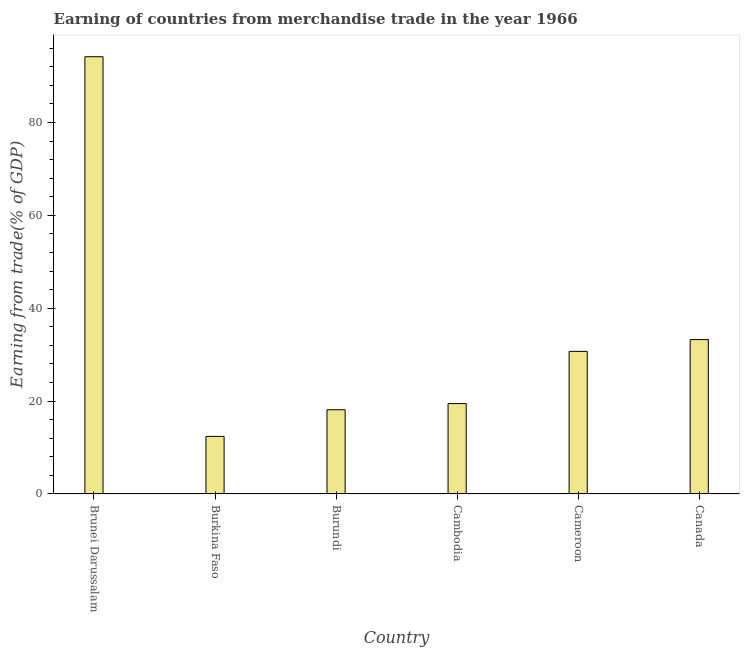Does the graph contain grids?
Keep it short and to the point. No. What is the title of the graph?
Provide a short and direct response. Earning of countries from merchandise trade in the year 1966. What is the label or title of the Y-axis?
Your answer should be compact. Earning from trade(% of GDP). What is the earning from merchandise trade in Cambodia?
Keep it short and to the point. 19.47. Across all countries, what is the maximum earning from merchandise trade?
Offer a very short reply. 94.16. Across all countries, what is the minimum earning from merchandise trade?
Give a very brief answer. 12.4. In which country was the earning from merchandise trade maximum?
Ensure brevity in your answer.  Brunei Darussalam. In which country was the earning from merchandise trade minimum?
Your response must be concise. Burkina Faso. What is the sum of the earning from merchandise trade?
Offer a terse response. 208.11. What is the difference between the earning from merchandise trade in Burkina Faso and Canada?
Provide a succinct answer. -20.85. What is the average earning from merchandise trade per country?
Make the answer very short. 34.69. What is the median earning from merchandise trade?
Keep it short and to the point. 25.09. In how many countries, is the earning from merchandise trade greater than 4 %?
Make the answer very short. 6. What is the ratio of the earning from merchandise trade in Cameroon to that in Canada?
Ensure brevity in your answer.  0.92. Is the difference between the earning from merchandise trade in Burkina Faso and Cameroon greater than the difference between any two countries?
Provide a succinct answer. No. What is the difference between the highest and the second highest earning from merchandise trade?
Provide a succinct answer. 60.91. Is the sum of the earning from merchandise trade in Burundi and Canada greater than the maximum earning from merchandise trade across all countries?
Give a very brief answer. No. What is the difference between the highest and the lowest earning from merchandise trade?
Give a very brief answer. 81.76. Are the values on the major ticks of Y-axis written in scientific E-notation?
Your response must be concise. No. What is the Earning from trade(% of GDP) in Brunei Darussalam?
Your answer should be compact. 94.16. What is the Earning from trade(% of GDP) in Burkina Faso?
Provide a succinct answer. 12.4. What is the Earning from trade(% of GDP) of Burundi?
Keep it short and to the point. 18.13. What is the Earning from trade(% of GDP) in Cambodia?
Make the answer very short. 19.47. What is the Earning from trade(% of GDP) in Cameroon?
Keep it short and to the point. 30.71. What is the Earning from trade(% of GDP) in Canada?
Offer a terse response. 33.25. What is the difference between the Earning from trade(% of GDP) in Brunei Darussalam and Burkina Faso?
Give a very brief answer. 81.76. What is the difference between the Earning from trade(% of GDP) in Brunei Darussalam and Burundi?
Give a very brief answer. 76.02. What is the difference between the Earning from trade(% of GDP) in Brunei Darussalam and Cambodia?
Keep it short and to the point. 74.69. What is the difference between the Earning from trade(% of GDP) in Brunei Darussalam and Cameroon?
Your answer should be compact. 63.45. What is the difference between the Earning from trade(% of GDP) in Brunei Darussalam and Canada?
Make the answer very short. 60.91. What is the difference between the Earning from trade(% of GDP) in Burkina Faso and Burundi?
Your answer should be very brief. -5.74. What is the difference between the Earning from trade(% of GDP) in Burkina Faso and Cambodia?
Make the answer very short. -7.07. What is the difference between the Earning from trade(% of GDP) in Burkina Faso and Cameroon?
Provide a succinct answer. -18.31. What is the difference between the Earning from trade(% of GDP) in Burkina Faso and Canada?
Offer a very short reply. -20.85. What is the difference between the Earning from trade(% of GDP) in Burundi and Cambodia?
Your answer should be very brief. -1.34. What is the difference between the Earning from trade(% of GDP) in Burundi and Cameroon?
Give a very brief answer. -12.58. What is the difference between the Earning from trade(% of GDP) in Burundi and Canada?
Provide a short and direct response. -15.11. What is the difference between the Earning from trade(% of GDP) in Cambodia and Cameroon?
Keep it short and to the point. -11.24. What is the difference between the Earning from trade(% of GDP) in Cambodia and Canada?
Ensure brevity in your answer.  -13.78. What is the difference between the Earning from trade(% of GDP) in Cameroon and Canada?
Ensure brevity in your answer.  -2.54. What is the ratio of the Earning from trade(% of GDP) in Brunei Darussalam to that in Burkina Faso?
Keep it short and to the point. 7.59. What is the ratio of the Earning from trade(% of GDP) in Brunei Darussalam to that in Burundi?
Give a very brief answer. 5.19. What is the ratio of the Earning from trade(% of GDP) in Brunei Darussalam to that in Cambodia?
Provide a succinct answer. 4.84. What is the ratio of the Earning from trade(% of GDP) in Brunei Darussalam to that in Cameroon?
Make the answer very short. 3.07. What is the ratio of the Earning from trade(% of GDP) in Brunei Darussalam to that in Canada?
Give a very brief answer. 2.83. What is the ratio of the Earning from trade(% of GDP) in Burkina Faso to that in Burundi?
Your answer should be compact. 0.68. What is the ratio of the Earning from trade(% of GDP) in Burkina Faso to that in Cambodia?
Offer a very short reply. 0.64. What is the ratio of the Earning from trade(% of GDP) in Burkina Faso to that in Cameroon?
Provide a succinct answer. 0.4. What is the ratio of the Earning from trade(% of GDP) in Burkina Faso to that in Canada?
Offer a very short reply. 0.37. What is the ratio of the Earning from trade(% of GDP) in Burundi to that in Cambodia?
Provide a succinct answer. 0.93. What is the ratio of the Earning from trade(% of GDP) in Burundi to that in Cameroon?
Offer a terse response. 0.59. What is the ratio of the Earning from trade(% of GDP) in Burundi to that in Canada?
Provide a short and direct response. 0.55. What is the ratio of the Earning from trade(% of GDP) in Cambodia to that in Cameroon?
Your answer should be compact. 0.63. What is the ratio of the Earning from trade(% of GDP) in Cambodia to that in Canada?
Keep it short and to the point. 0.59. What is the ratio of the Earning from trade(% of GDP) in Cameroon to that in Canada?
Your answer should be very brief. 0.92. 